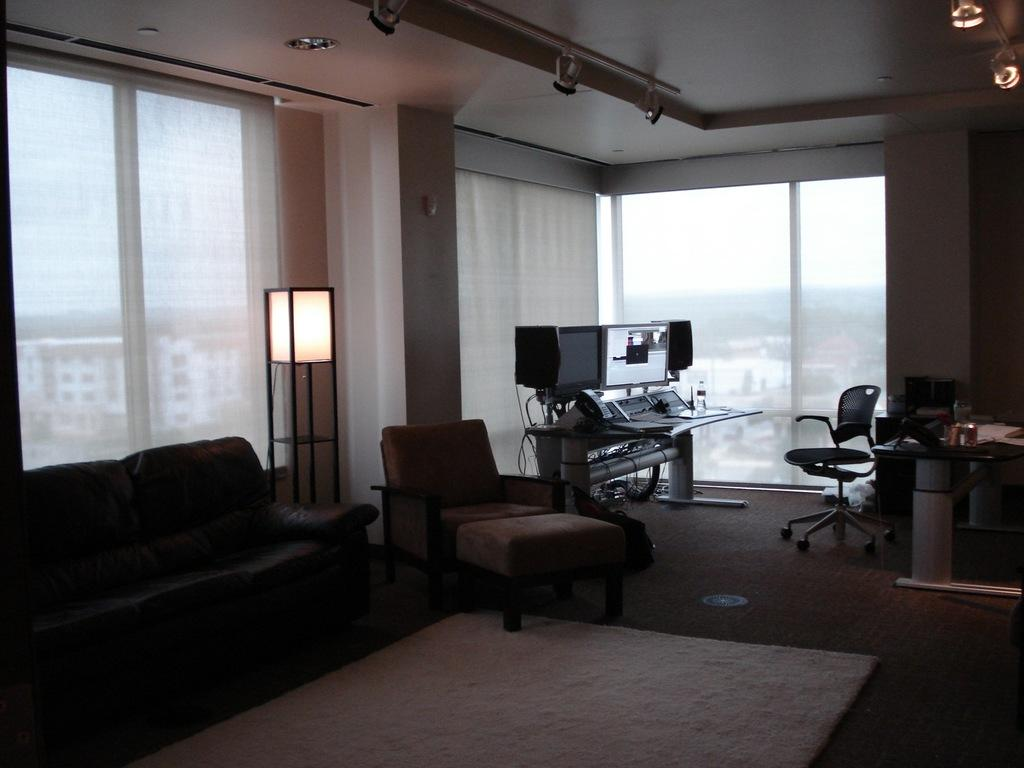What can be seen through the window in the image? Buildings are visible through the window in the image. What type of flooring is present in the image? There is a floor with a carpet in the image. What electronic devices are on the table in the image? There are monitors on a table in the image. What furniture is located beside the couch in the image? There is a chair and lamp beside the couch in the image. What type of lighting is visible in the image? There are lights visible in the image. Can you tell me how many cherries are on the table in the image? There are no cherries present in the image. What type of transport is visible in the image? There is no transport visible in the image. 